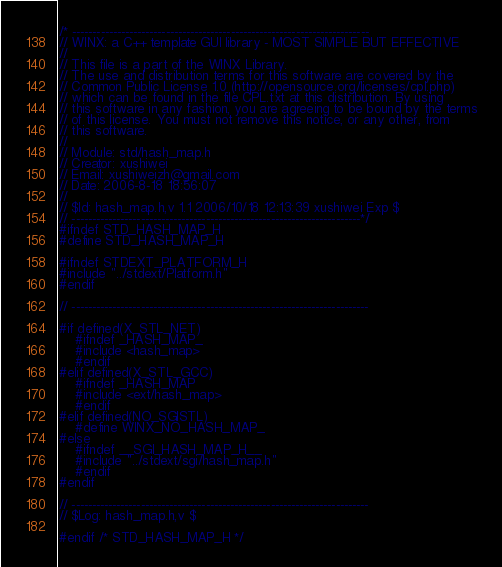<code> <loc_0><loc_0><loc_500><loc_500><_C_>/* -------------------------------------------------------------------------
// WINX: a C++ template GUI library - MOST SIMPLE BUT EFFECTIVE
// 
// This file is a part of the WINX Library.
// The use and distribution terms for this software are covered by the
// Common Public License 1.0 (http://opensource.org/licenses/cpl.php)
// which can be found in the file CPL.txt at this distribution. By using
// this software in any fashion, you are agreeing to be bound by the terms
// of this license. You must not remove this notice, or any other, from
// this software.
// 
// Module: std/hash_map.h
// Creator: xushiwei
// Email: xushiweizh@gmail.com
// Date: 2006-8-18 18:56:07
// 
// $Id: hash_map.h,v 1.1 2006/10/18 12:13:39 xushiwei Exp $
// -----------------------------------------------------------------------*/
#ifndef STD_HASH_MAP_H
#define STD_HASH_MAP_H

#ifndef STDEXT_PLATFORM_H
#include "../stdext/Platform.h"
#endif

// -------------------------------------------------------------------------

#if defined(X_STL_NET)
	#ifndef _HASH_MAP_
	#include <hash_map>
	#endif
#elif defined(X_STL_GCC)
	#ifndef _HASH_MAP
	#include <ext/hash_map>
	#endif
#elif defined(NO_SGISTL)
	#define WINX_NO_HASH_MAP_
#else
	#ifndef __SGI_HASH_MAP_H__
	#include "../stdext/sgi/hash_map.h"
	#endif
#endif

// -------------------------------------------------------------------------
// $Log: hash_map.h,v $

#endif /* STD_HASH_MAP_H */
</code> 